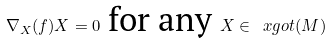Convert formula to latex. <formula><loc_0><loc_0><loc_500><loc_500>\nabla _ { X } ( f ) X = 0 \text { for any } X \in \ x g o t ( M )</formula> 